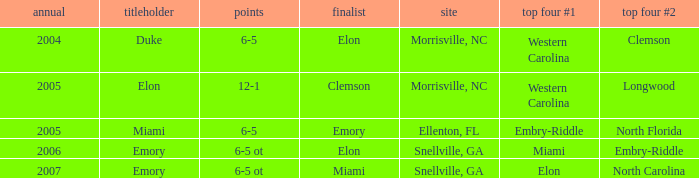When Embry-Riddle made it to the first semi finalist slot, list all the runners up. Emory. 